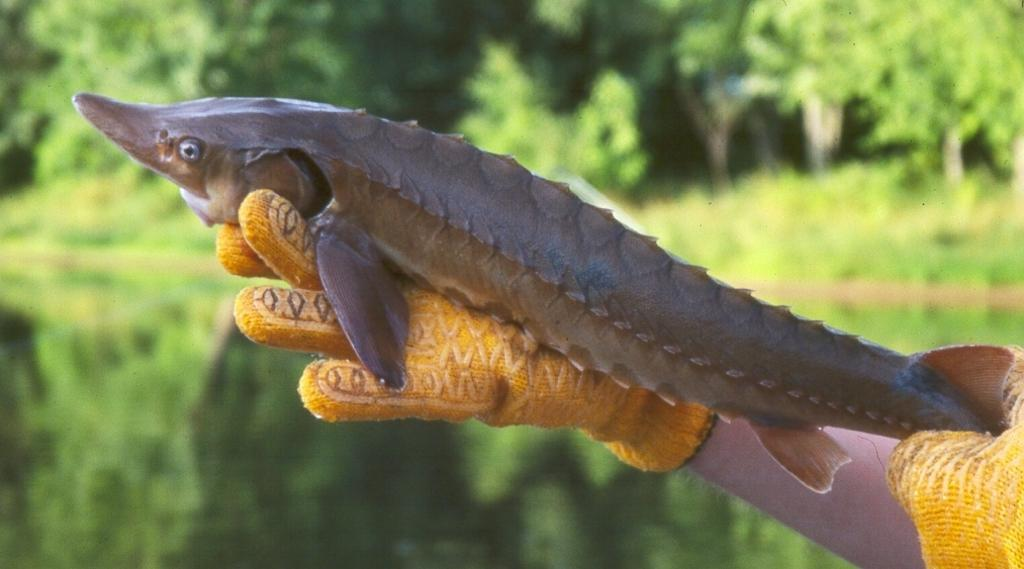What is the person in the image holding? The person is holding a fish in the image. What can be seen in the background of the image? There is water and trees visible in the background of the image. Where is the throne located in the image? There is no throne present in the image. What letter is being held by the person in the image? The person is holding a fish, not a letter, in the image. 